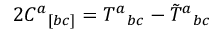Convert formula to latex. <formula><loc_0><loc_0><loc_500><loc_500>2 C ^ { a _ { [ b c ] } = T ^ { a _ { b c } - \tilde { T ^ { a _ { b c }</formula> 